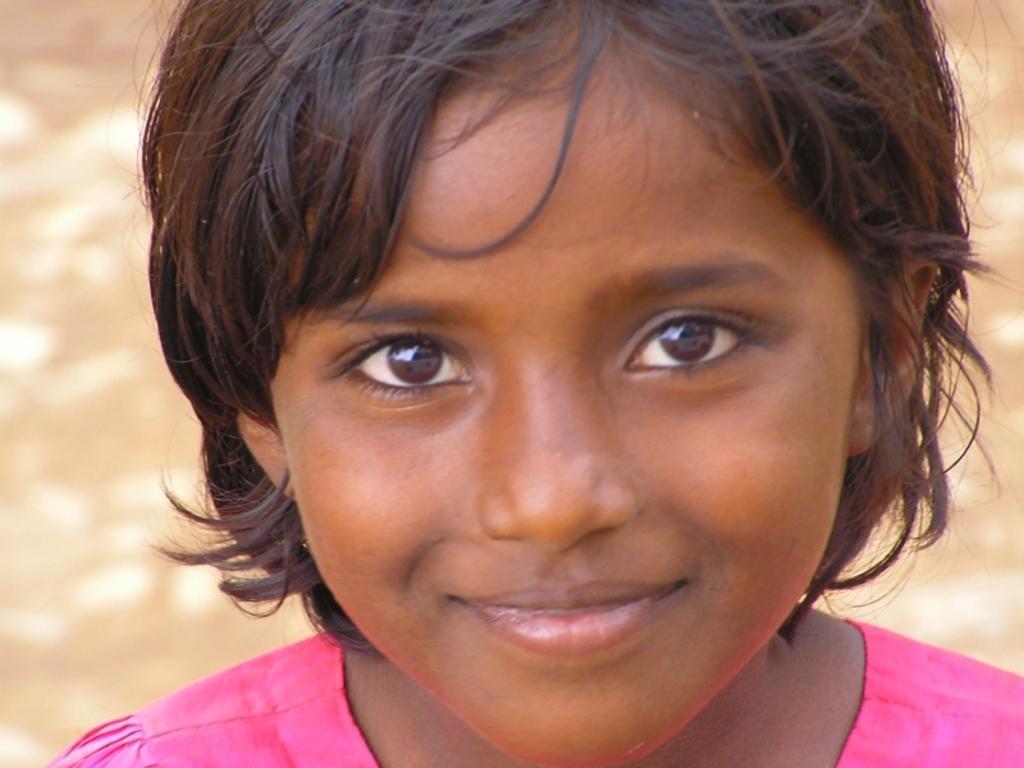Could you give a brief overview of what you see in this image? In this image, we can see a girl, in the background, we can see brown color. 